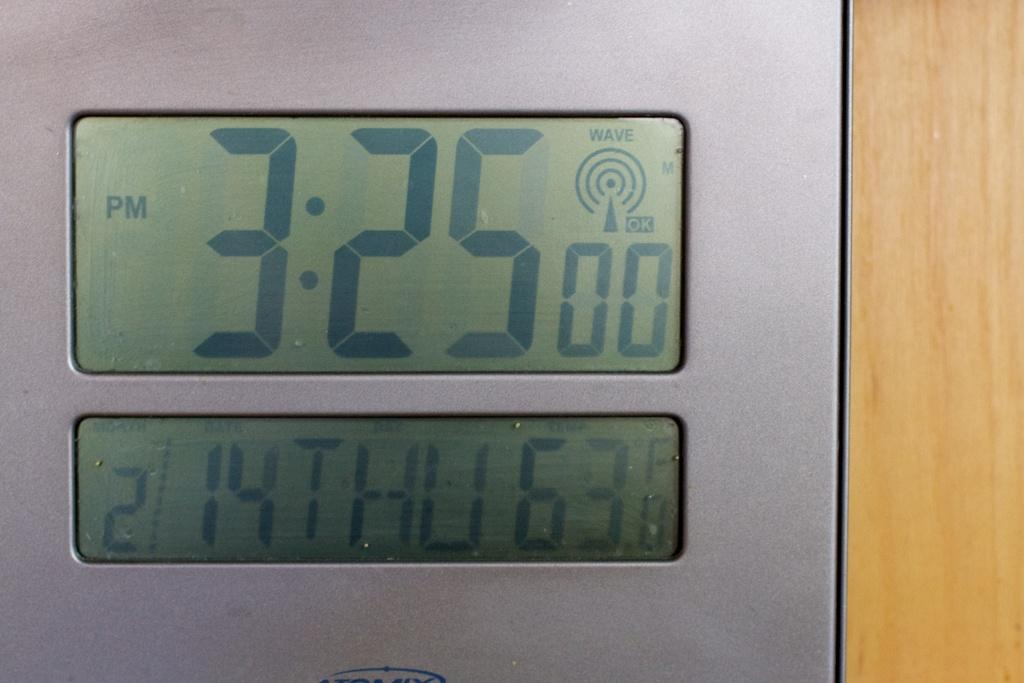Provide a one-sentence caption for the provided image. The clock says 3:25 pm on 2/14 Thursday. 